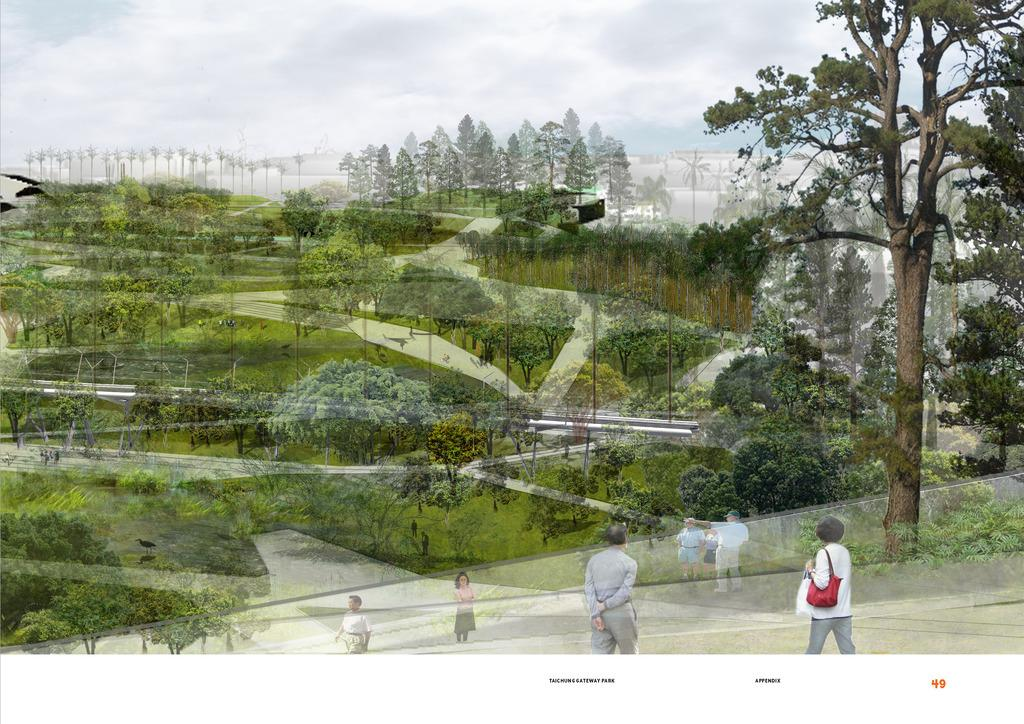What type of surface can be seen in the image? The ground is visible in the image. What type of vegetation is present in the image? There is grass, plants, and trees in the image. Are there any living beings in the image? Yes, there are people in the image. What is visible in the background of the image? The sky is visible in the image, and clouds are present in the sky. What reason does the drawer have for being in the image? There is no drawer present in the image, so it cannot have a reason for being there. 